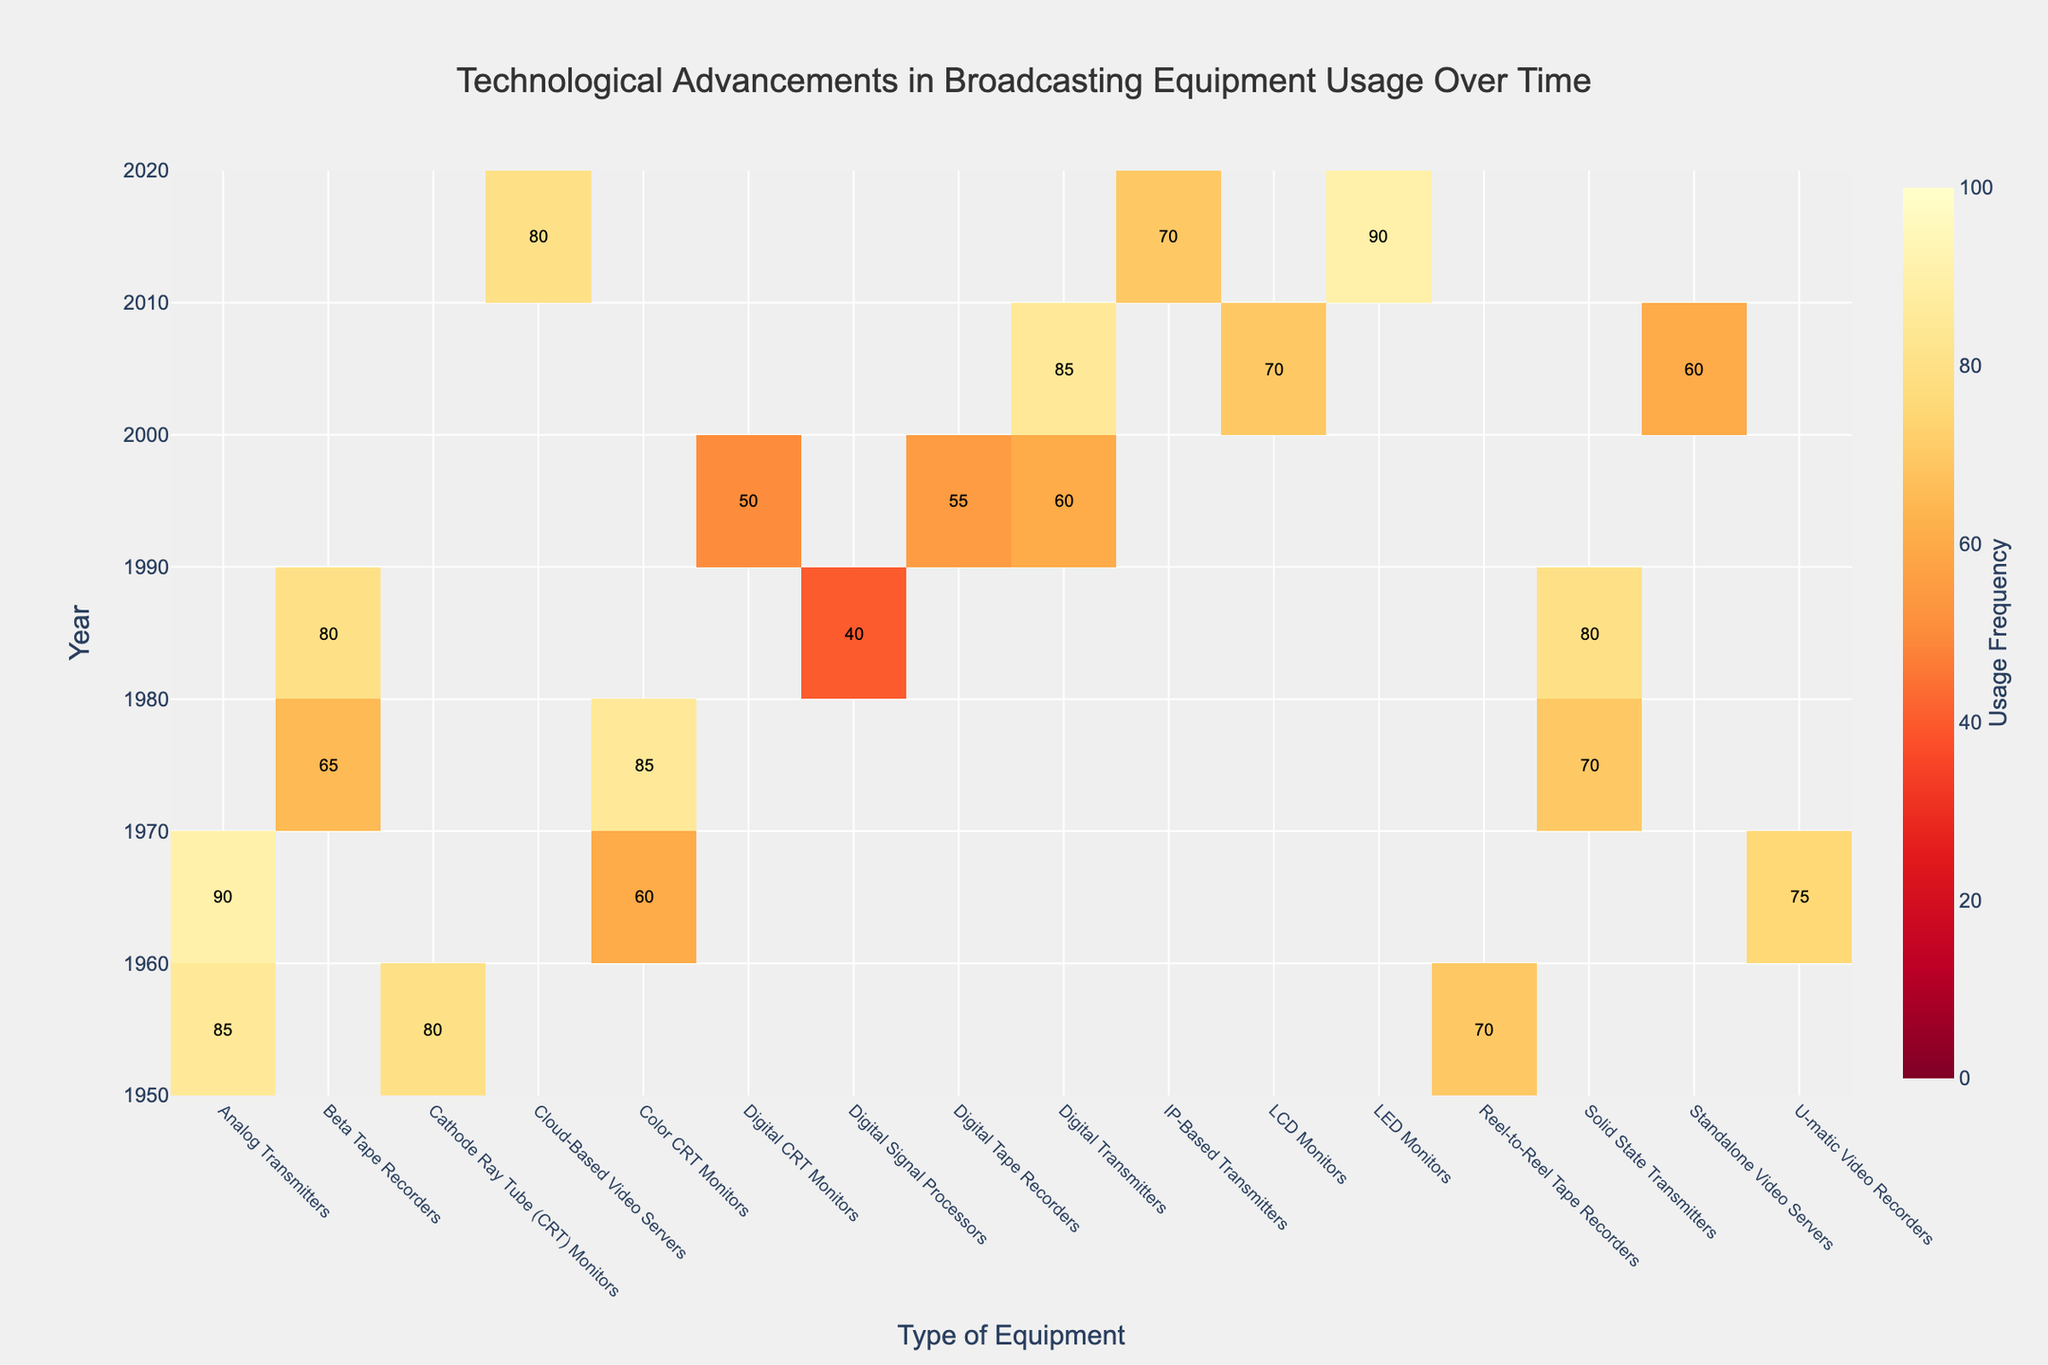What year saw the highest usage frequency of Analog Transmitters? Look at the "Analog Transmitters" column and find the year with the darkest shade, which indicates the highest frequency. Based on its position on the y-axis, you will see that 1965 has the highest usage frequency at 90.
Answer: 1965 How did the usage frequency of CRT Monitors change from 1955 to 1975? Compare the values for "CRT Monitors" in 1955 and in 1975. Cathode Ray Tube (CRT) Monitors had a usage frequency of 80 in 1955 and Color CRT Monitors had a usage frequency of 85 in 1975. This is an increase of 5.
Answer: Increased by 5 Which equipment in 2005 had the highest usage frequency? Check the 2005 row and find the highest frequency value. Note the corresponding equipment type, which is Digital Transmitters with a frequency of 85.
Answer: Digital Transmitters Were there any years when Beta Tape Recorders had the same usage frequency twice? Look in the "Beta Tape Recorders" column and see if there is any repeated frequency. Beta Tape Recorders in 1975 and 1985 both had a frequency of 80.
Answer: Yes, in 1985 and 1975 What can you infer about the usage of Solid State Transmitters over time? Examine the "Solid State Transmitters" values over the years. In 1975 it had a frequency of 70 and in 1985 it was 80. Between 1975 and 1985, there was an increase.
Answer: Increased over time Which year shows the highest usage frequency for LED Monitors? Find the year associated with "LED Monitors" and note its usage frequency. The highest frequency for LED Monitors is in the year 2015 with 90.
Answer: 2015 What was the frequency difference between Digital CRT Monitors in 1995 and LCD Monitors in 2005? Calculate the difference between the frequency values for Digital CRT Monitors in 1995 (50) and LCD Monitors in 2005 (70). The difference is 70 - 50 = 20.
Answer: 20 Which type of equipment had the lowest usage frequency over all the years? Look for the smallest number visible in the heatmap and identify the corresponding equipment types and years. Digital Signal Processors in 1985 had the lowest frequency of 40.
Answer: Digital Signal Processors How did the frequency of IP-Based Transmitters in 2015 compare with Digital Transmitters in 2005? Compare the values for IP-Based Transmitters in 2015 (70) and Digital Transmitters in 2005 (85). The IP-Based Transmitters had a lower frequency by 15.
Answer: Lower by 15 Which piece of equipment introduced in 1995 had a higher usage, Digital Transmitters or Digital Tape Recorders? Compare the usage frequencies for Digital Transmitters and Digital Tape Recorders in 1995. Digital Transmitters had a frequency of 60, while Digital Tape Recorders had a frequency of 55.
Answer: Digital Transmitters 